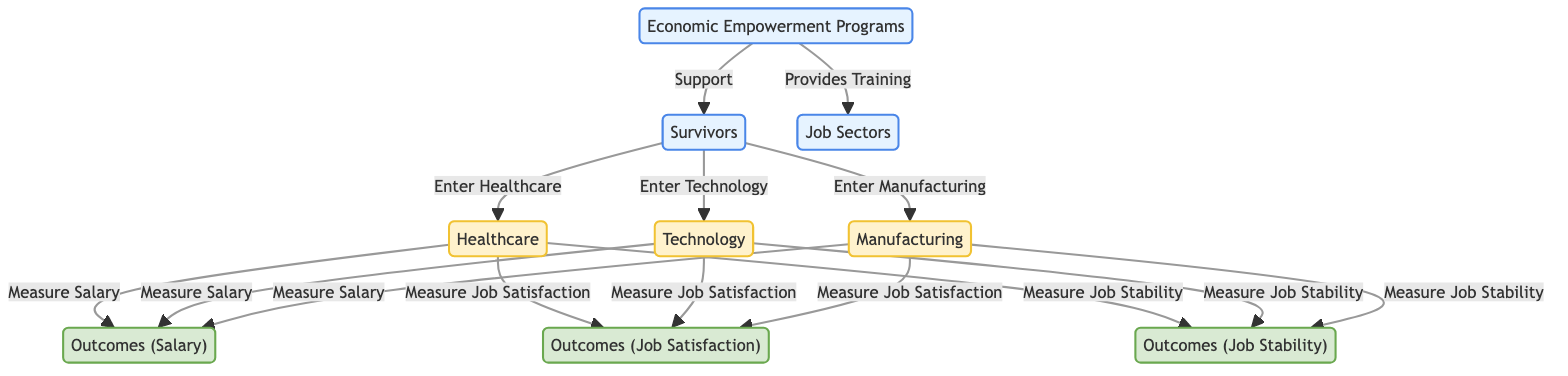What are the three job sectors mentioned in the diagram? The diagram shows three job sectors: Healthcare, Technology, and Manufacturing. These can be easily identified as directly connected nodes stemming from the "Survivors" node under the input category.
Answer: Healthcare, Technology, Manufacturing How many outcomes are measured for each job sector? The diagram indicates that there are three outcomes measured for each job sector, specifically: Salary, Job Satisfaction, and Job Stability, as shown by the output nodes connected to each job sector.
Answer: Three What type of support do the Economic Empowerment Programs provide? The Economic Empowerment Programs provide two types of support: they support survivors and provide training, both of which are shown as directed edges from the "Economic Empowerment Programs" node.
Answer: Support, Provides Training Which job sector measures job stability? All three job sectors—Healthcare, Technology, and Manufacturing—measure job stability, as indicated by the connections from each sector to the "Outcomes (Job Stability)" output node.
Answer: Healthcare, Technology, Manufacturing What is the last step in the flow for measuring an outcome in healthcare? The last step for measuring an outcome in the healthcare sector is to measure Job Stability, which is the final action taken following the connection from the Job sector to the outcome node.
Answer: Measure Job Stability In total, how many nodes are directly connected to the "Survivors" node? The "Survivors" node is connected to three nodes representing the job sectors, indicating that a total of three direct connections (edges) exist from the "Survivors" node to the job sectors in the diagram.
Answer: Three What outcome is measured for technology alongside salary? Job Satisfaction is the outcome that is measured for the Technology job sector alongside Salary, as represented by the edges connecting Technology to both outcome nodes.
Answer: Job Satisfaction How does the flow of the diagram start? The flow of the diagram begins with the "Economic Empowerment Programs" node, which supports the "Survivors" node, indicating the initial point of data flow in the diagram.
Answer: Economic Empowerment Programs 